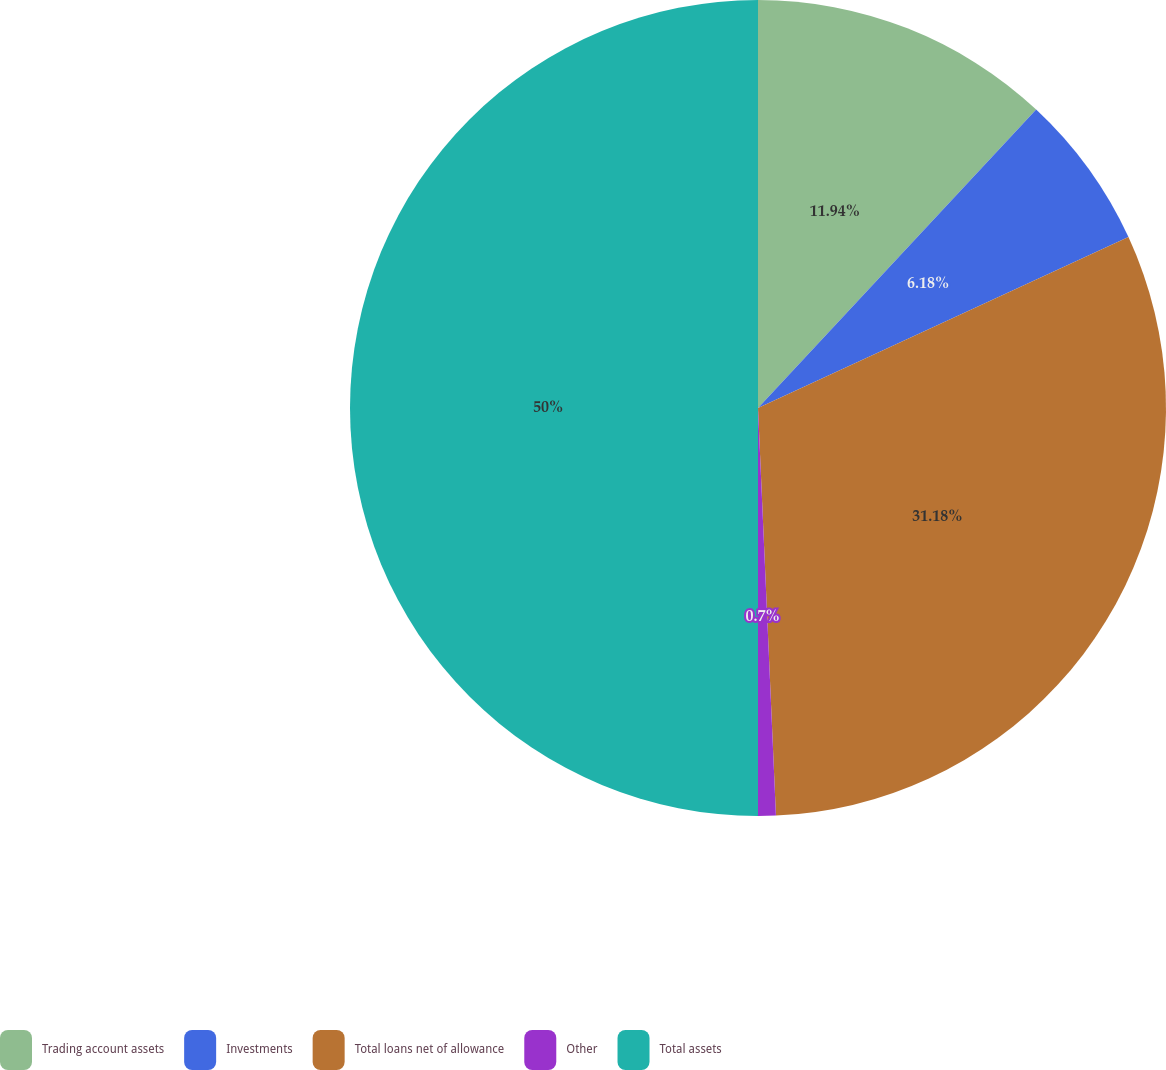Convert chart. <chart><loc_0><loc_0><loc_500><loc_500><pie_chart><fcel>Trading account assets<fcel>Investments<fcel>Total loans net of allowance<fcel>Other<fcel>Total assets<nl><fcel>11.94%<fcel>6.18%<fcel>31.18%<fcel>0.7%<fcel>50.0%<nl></chart> 